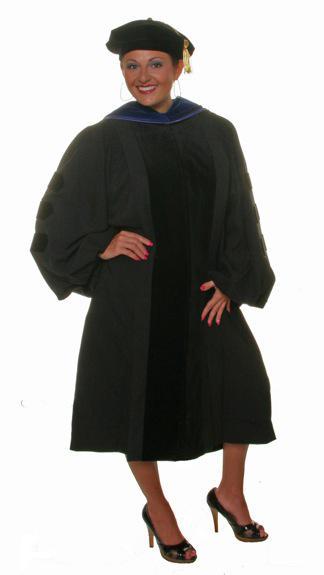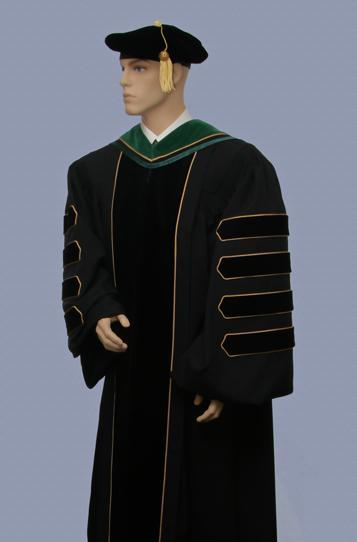The first image is the image on the left, the second image is the image on the right. Considering the images on both sides, is "A graduation gown option includes a short red scarf that stops at the waist." valid? Answer yes or no. No. 